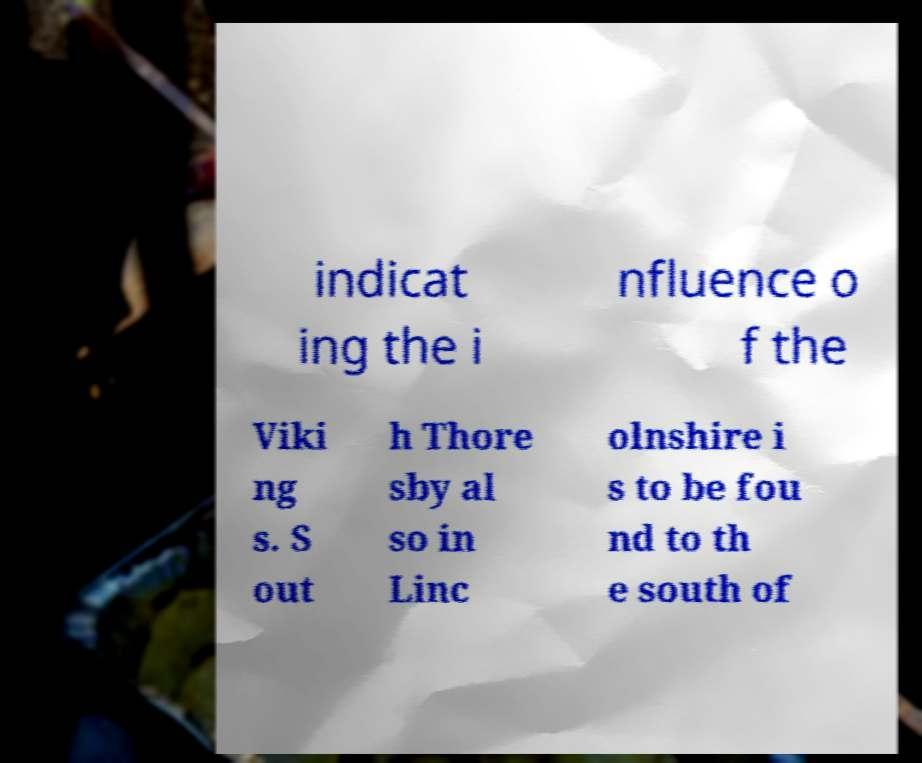There's text embedded in this image that I need extracted. Can you transcribe it verbatim? indicat ing the i nfluence o f the Viki ng s. S out h Thore sby al so in Linc olnshire i s to be fou nd to th e south of 